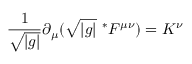<formula> <loc_0><loc_0><loc_500><loc_500>\frac { 1 } { \sqrt { | g | } } \partial _ { \mu } ( \sqrt { | g | } \ ^ { * } F ^ { \mu \nu } ) = K ^ { \nu }</formula> 